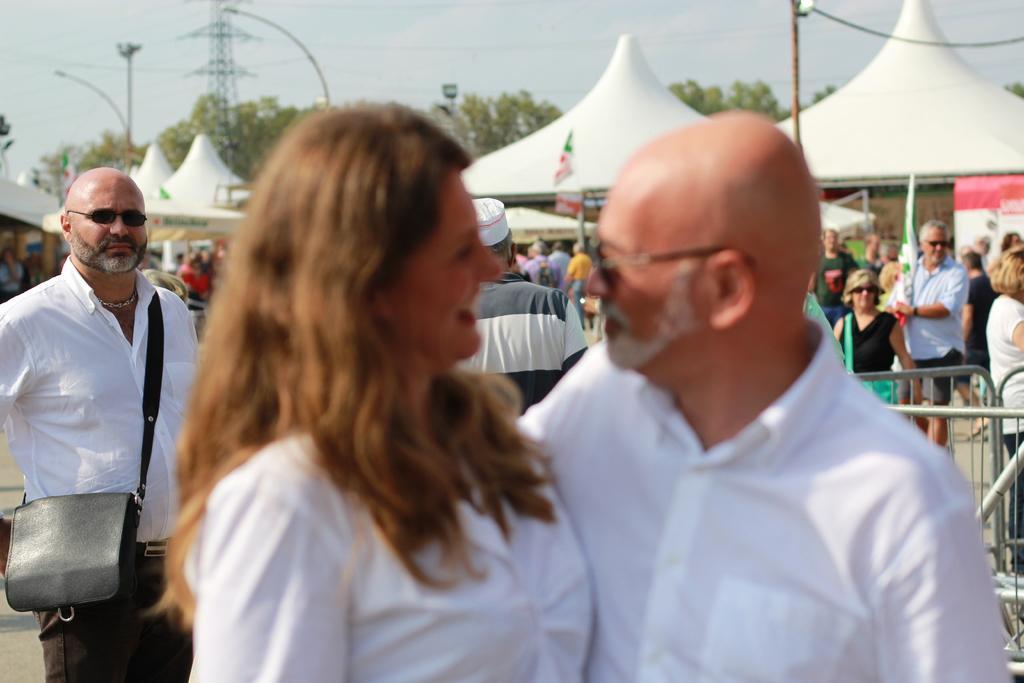Describe this image in one or two sentences. In the center of the image there are two people standing, wearing white color dress. In the background of the image there are many people. There are trees. 